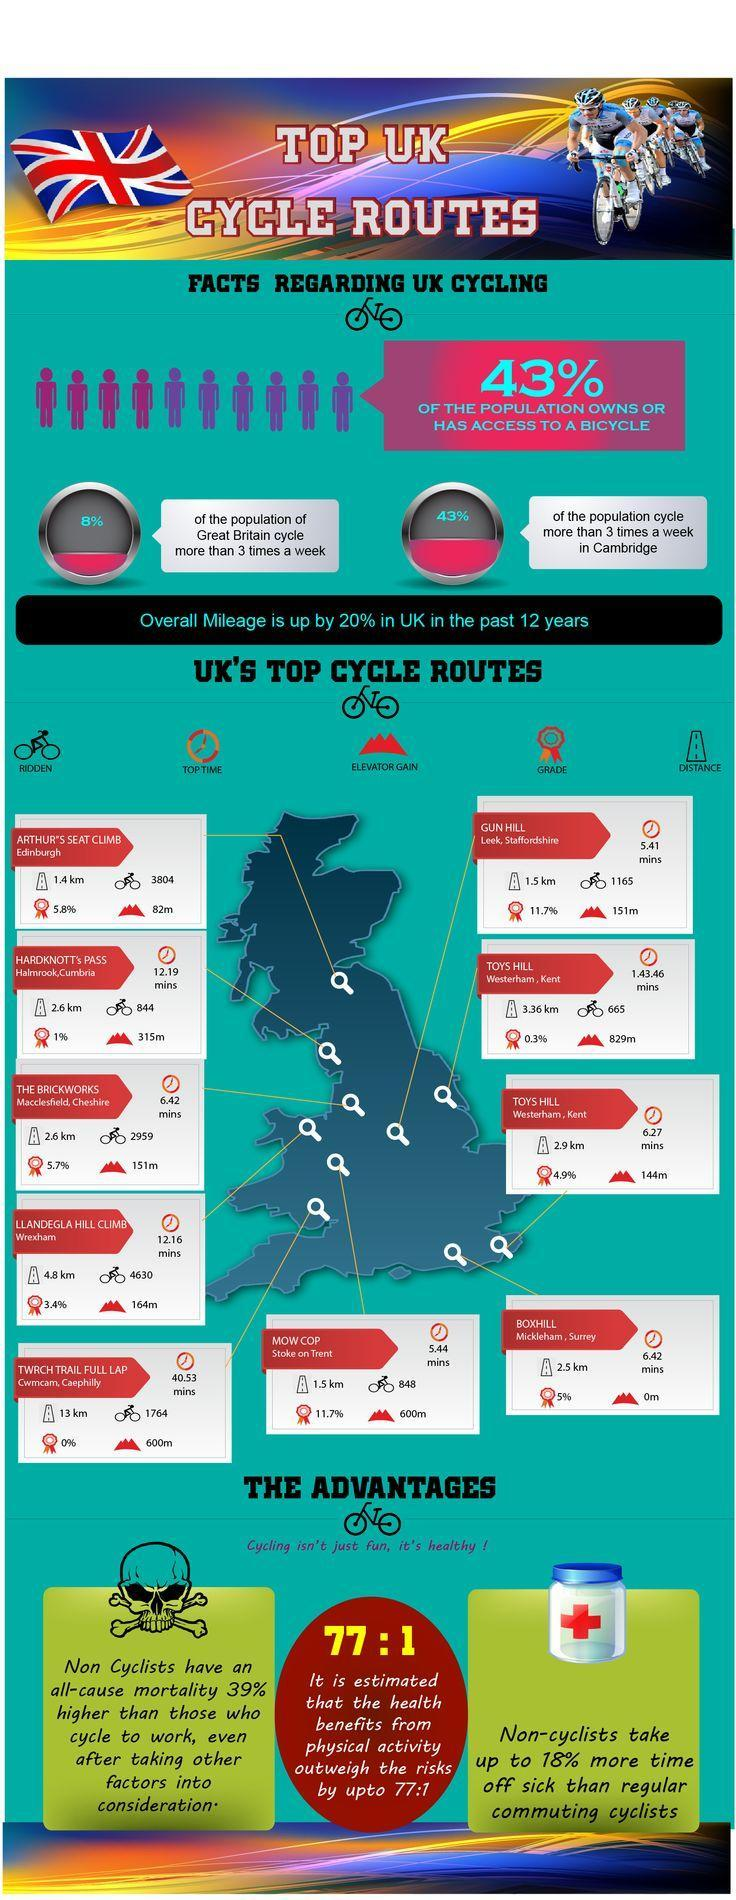What percent of population do not own or has no access to a bicycle?
Answer the question with a short phrase. 57% 